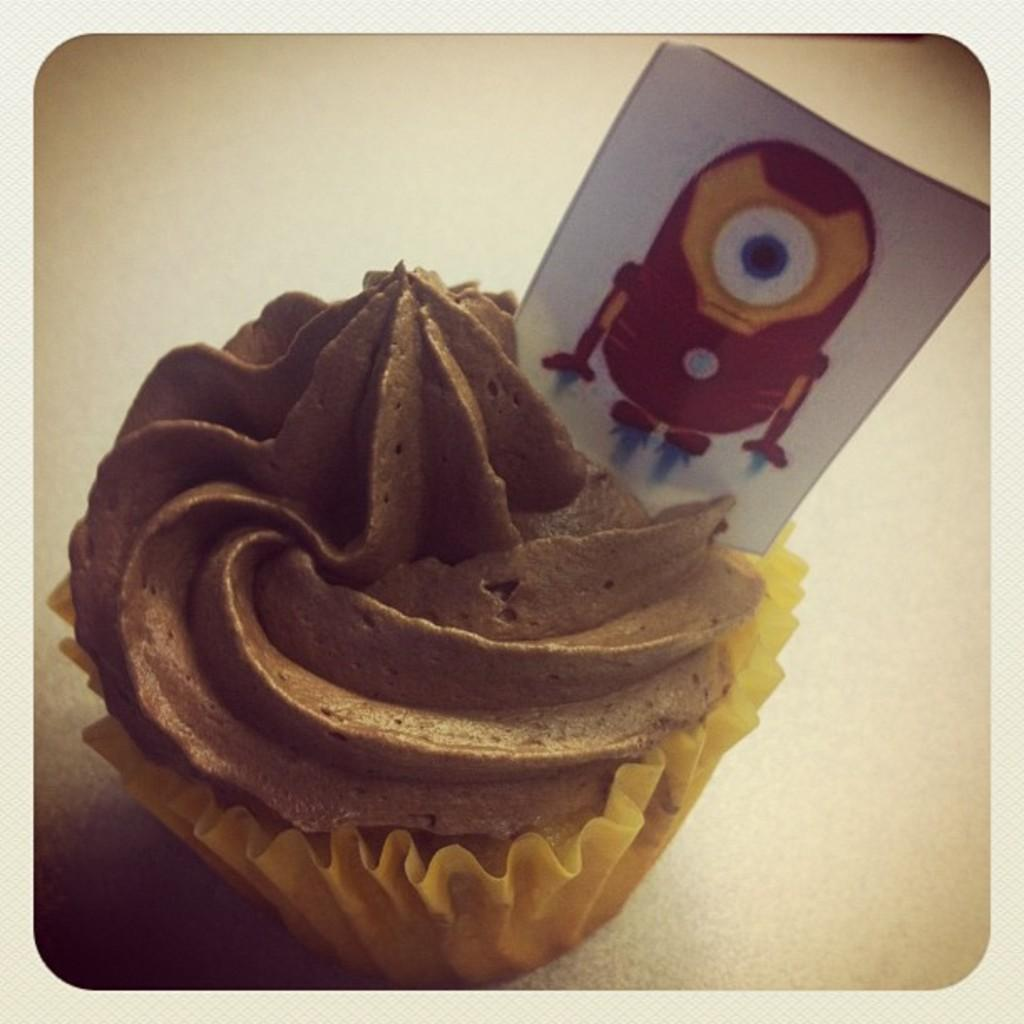What type of dessert can be seen in the image? There is a cupcake in the image. Is there anything unusual about the cupcake? Yes, there is a board on the cupcake. What type of star can be seen on the trousers in the image? There are no trousers or stars present in the image; it only features a cupcake with a board on it. 